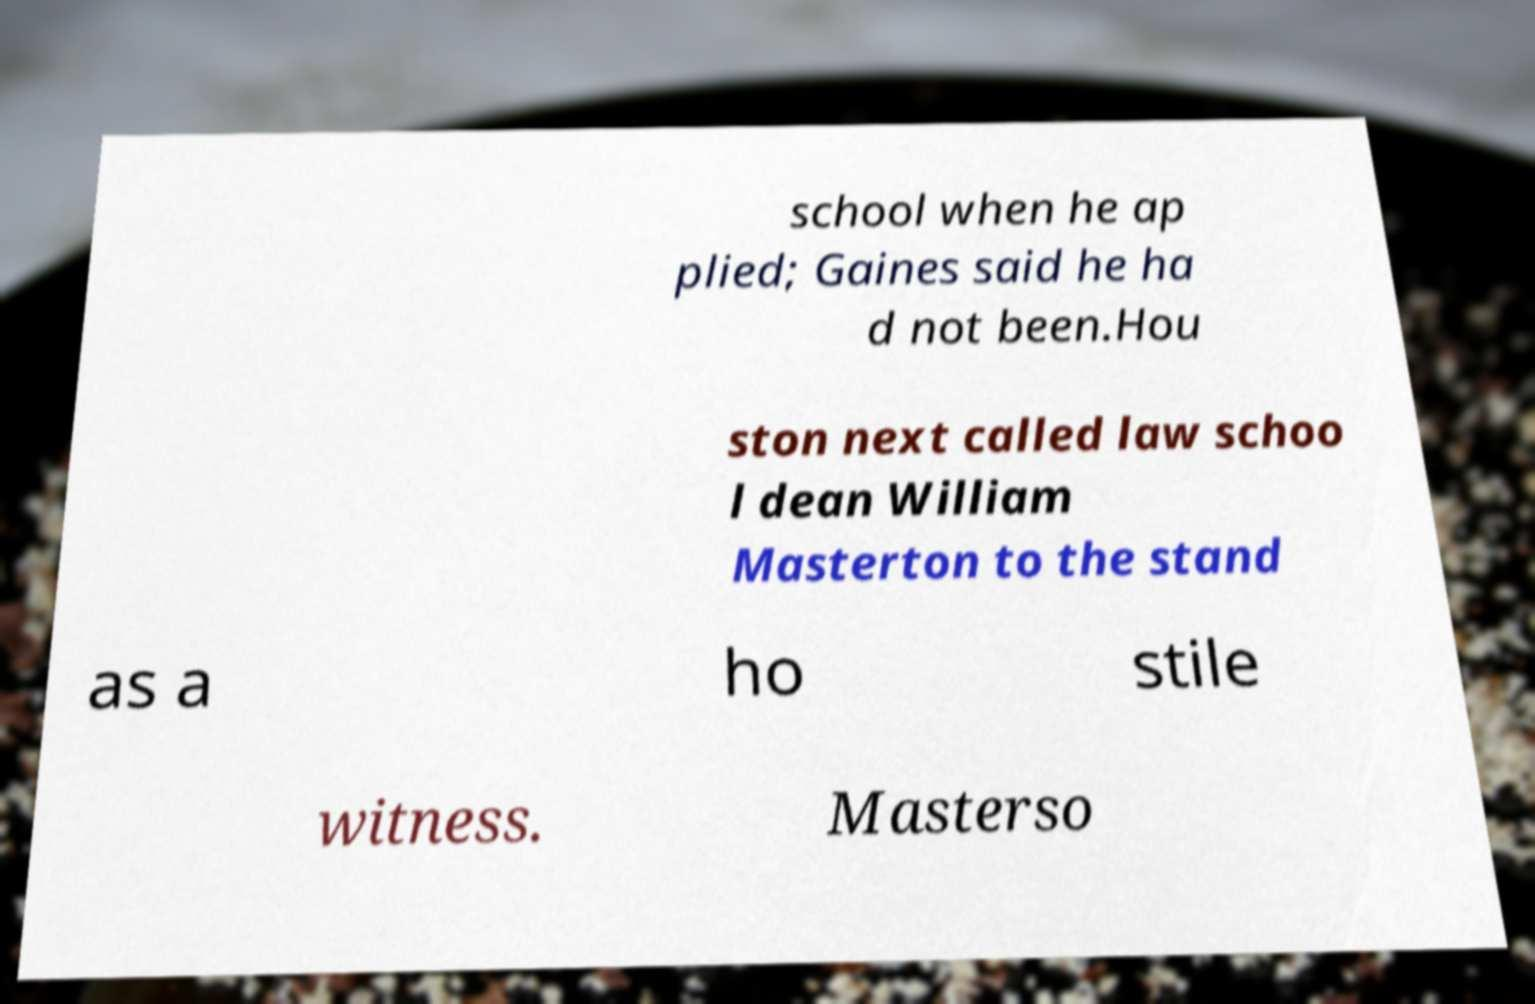Can you accurately transcribe the text from the provided image for me? school when he ap plied; Gaines said he ha d not been.Hou ston next called law schoo l dean William Masterton to the stand as a ho stile witness. Masterso 